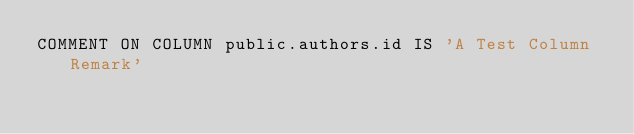Convert code to text. <code><loc_0><loc_0><loc_500><loc_500><_SQL_>COMMENT ON COLUMN public.authors.id IS 'A Test Column Remark'</code> 